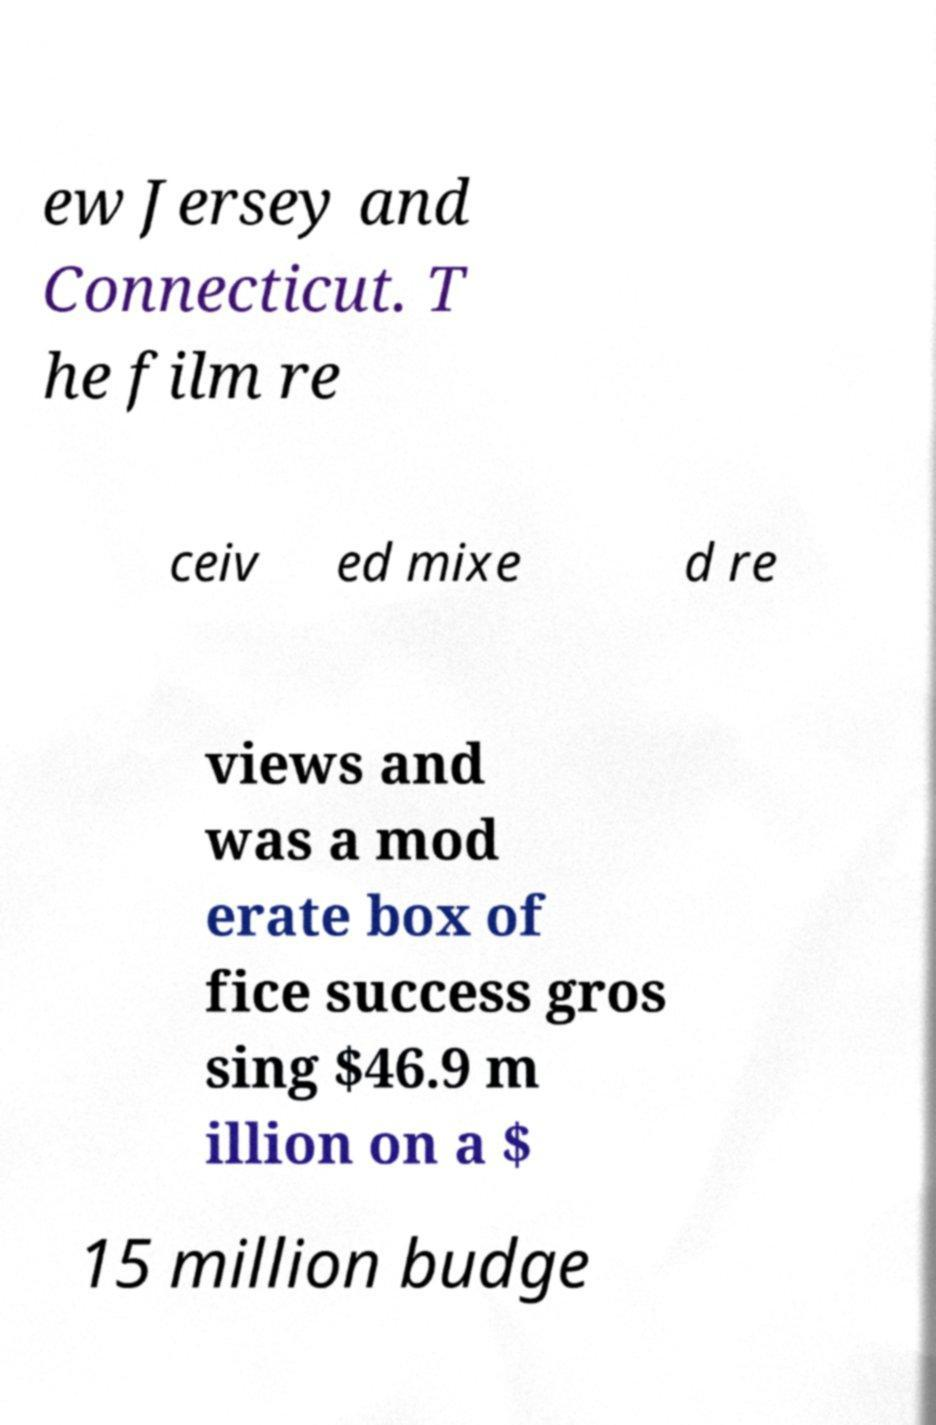Could you extract and type out the text from this image? ew Jersey and Connecticut. T he film re ceiv ed mixe d re views and was a mod erate box of fice success gros sing $46.9 m illion on a $ 15 million budge 